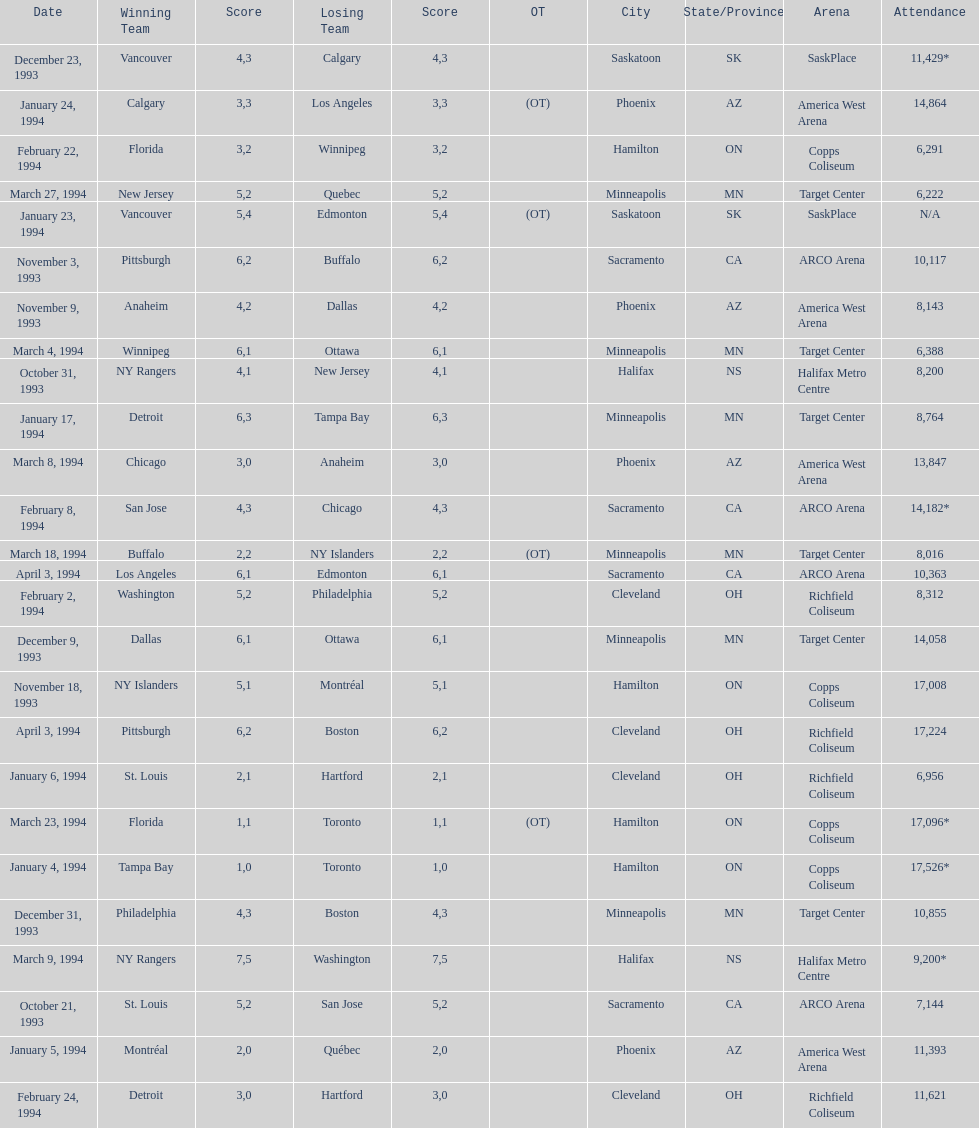How many neutral site games resulted in overtime (ot)? 4. 